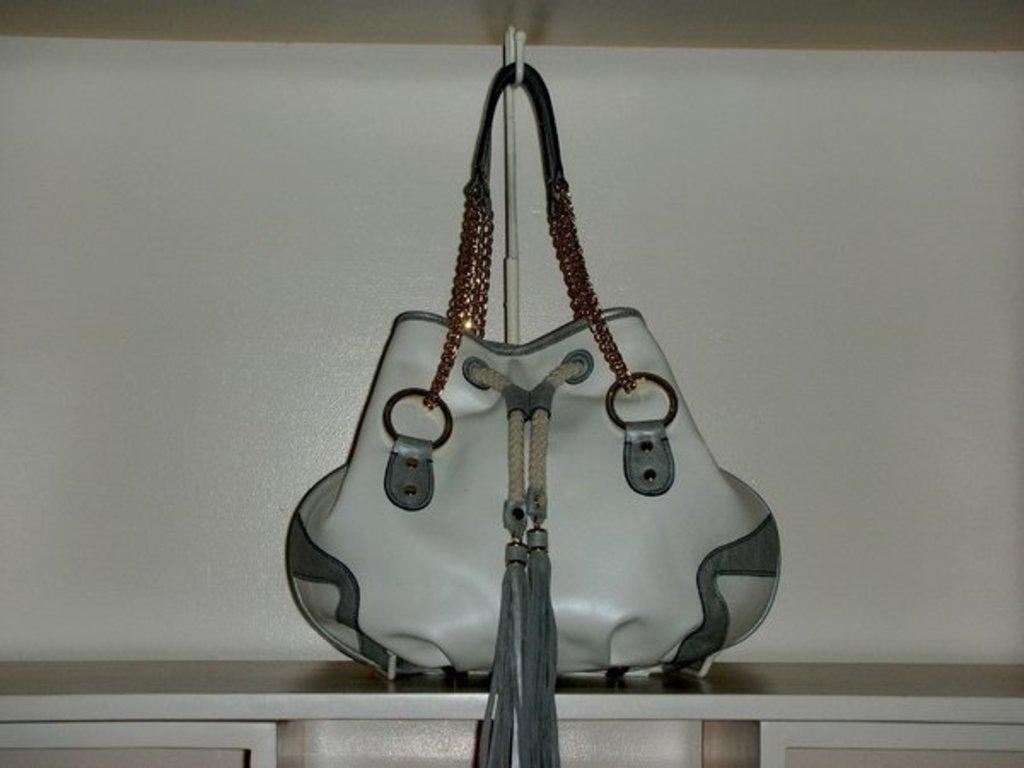How would you summarize this image in a sentence or two? In this picture we can see a bag with chain hanged to the handler and this bag is in white color and this is placed on a rack and in the background we can see white color wall. 